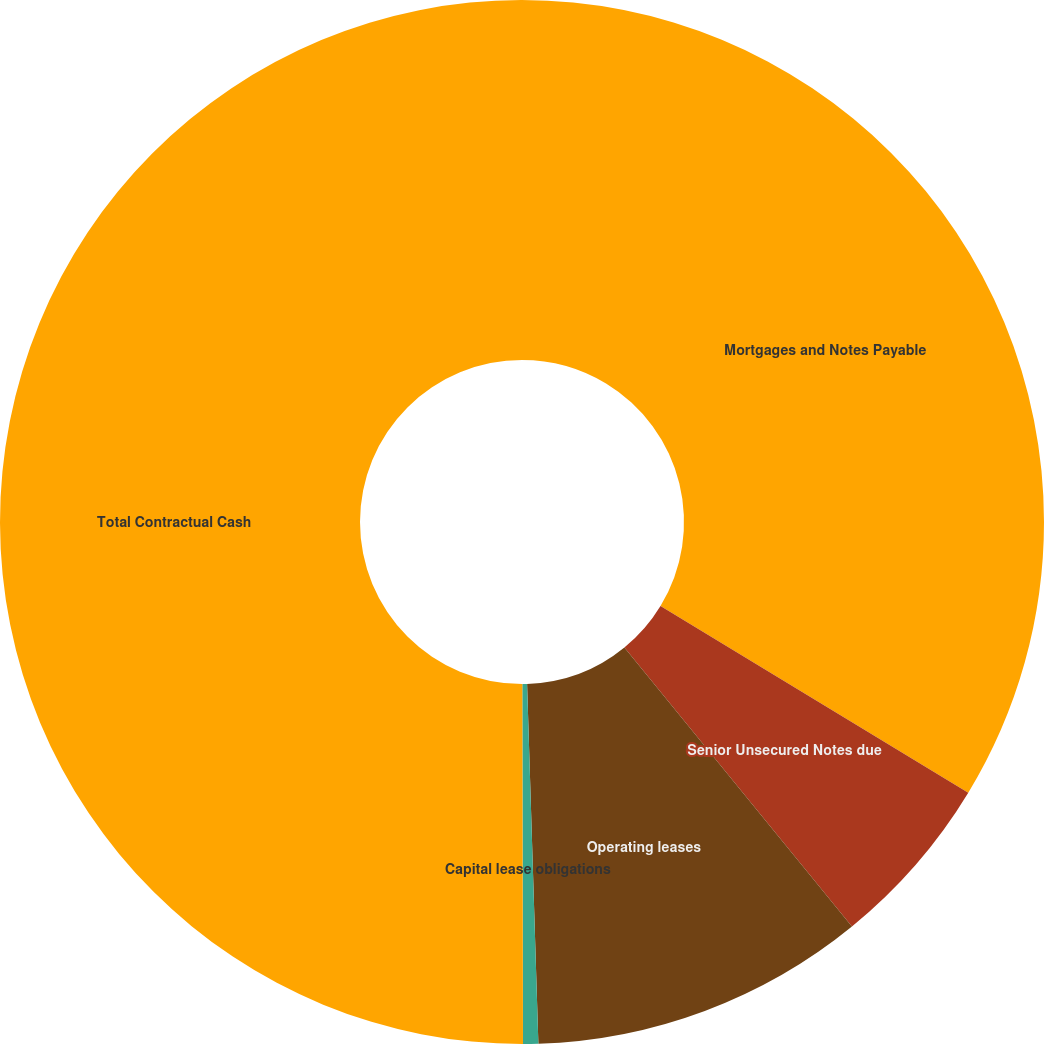<chart> <loc_0><loc_0><loc_500><loc_500><pie_chart><fcel>Mortgages and Notes Payable<fcel>Senior Unsecured Notes due<fcel>Operating leases<fcel>Capital lease obligations<fcel>Total Contractual Cash<nl><fcel>33.68%<fcel>5.43%<fcel>10.39%<fcel>0.47%<fcel>50.03%<nl></chart> 